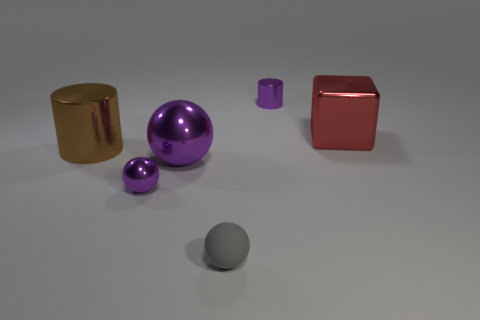What shape is the large metal thing that is the same color as the tiny metal cylinder?
Give a very brief answer. Sphere. There is another small object that is the same shape as the gray rubber thing; what is it made of?
Your response must be concise. Metal. There is a large object that is both right of the big brown object and left of the purple cylinder; what color is it?
Your answer should be compact. Purple. Are there any shiny things that are on the right side of the cylinder that is left of the purple thing that is behind the big red thing?
Make the answer very short. Yes. How many things are either tiny purple metallic spheres or large brown cylinders?
Provide a succinct answer. 2. Are the brown thing and the big thing that is right of the small gray rubber thing made of the same material?
Provide a succinct answer. Yes. Is there any other thing of the same color as the matte ball?
Provide a short and direct response. No. How many things are tiny purple objects in front of the purple metallic cylinder or metal things that are right of the small gray matte object?
Ensure brevity in your answer.  3. What shape is the metallic thing that is both on the left side of the large red metal block and to the right of the gray rubber object?
Offer a terse response. Cylinder. What number of big brown cylinders are right of the small object behind the large shiny block?
Give a very brief answer. 0. 